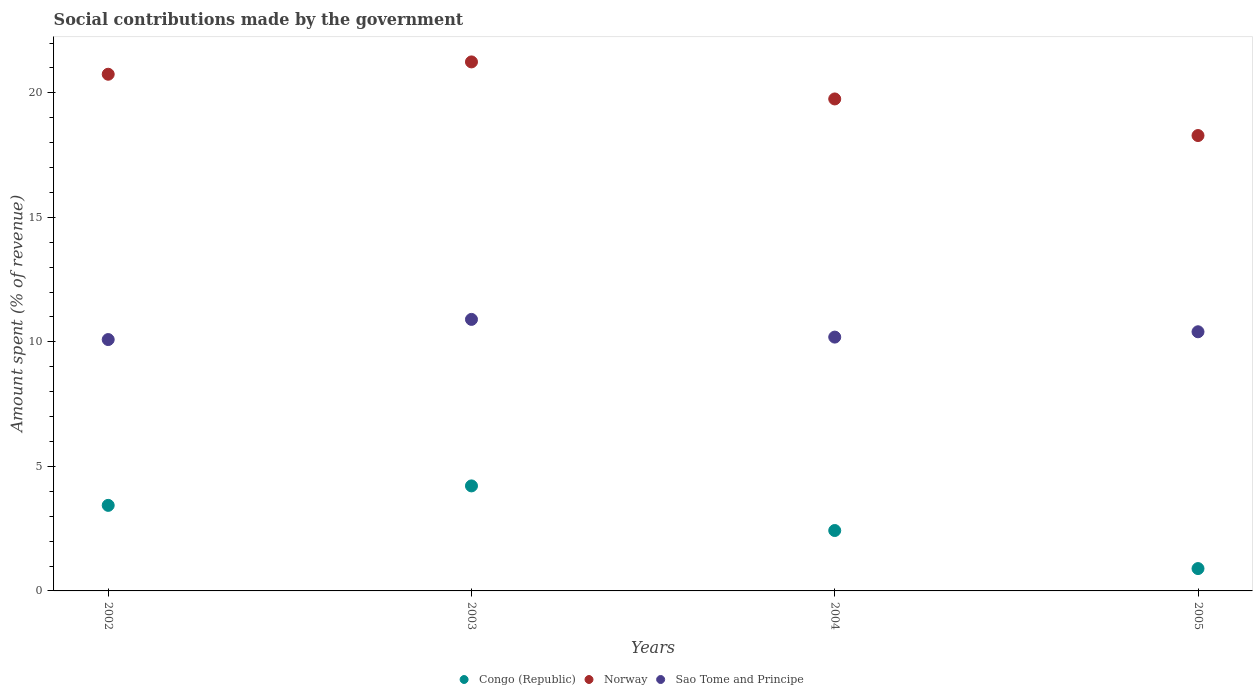What is the amount spent (in %) on social contributions in Congo (Republic) in 2003?
Keep it short and to the point. 4.22. Across all years, what is the maximum amount spent (in %) on social contributions in Sao Tome and Principe?
Offer a terse response. 10.9. Across all years, what is the minimum amount spent (in %) on social contributions in Sao Tome and Principe?
Make the answer very short. 10.09. In which year was the amount spent (in %) on social contributions in Sao Tome and Principe maximum?
Provide a succinct answer. 2003. What is the total amount spent (in %) on social contributions in Congo (Republic) in the graph?
Provide a succinct answer. 10.98. What is the difference between the amount spent (in %) on social contributions in Congo (Republic) in 2002 and that in 2003?
Offer a terse response. -0.78. What is the difference between the amount spent (in %) on social contributions in Norway in 2004 and the amount spent (in %) on social contributions in Congo (Republic) in 2005?
Your answer should be compact. 18.86. What is the average amount spent (in %) on social contributions in Congo (Republic) per year?
Your answer should be very brief. 2.74. In the year 2005, what is the difference between the amount spent (in %) on social contributions in Sao Tome and Principe and amount spent (in %) on social contributions in Norway?
Give a very brief answer. -7.88. In how many years, is the amount spent (in %) on social contributions in Sao Tome and Principe greater than 15 %?
Make the answer very short. 0. What is the ratio of the amount spent (in %) on social contributions in Norway in 2003 to that in 2005?
Your response must be concise. 1.16. What is the difference between the highest and the second highest amount spent (in %) on social contributions in Sao Tome and Principe?
Offer a very short reply. 0.5. What is the difference between the highest and the lowest amount spent (in %) on social contributions in Sao Tome and Principe?
Your response must be concise. 0.81. Is the sum of the amount spent (in %) on social contributions in Congo (Republic) in 2003 and 2005 greater than the maximum amount spent (in %) on social contributions in Norway across all years?
Give a very brief answer. No. Is it the case that in every year, the sum of the amount spent (in %) on social contributions in Congo (Republic) and amount spent (in %) on social contributions in Sao Tome and Principe  is greater than the amount spent (in %) on social contributions in Norway?
Ensure brevity in your answer.  No. Is the amount spent (in %) on social contributions in Norway strictly greater than the amount spent (in %) on social contributions in Sao Tome and Principe over the years?
Give a very brief answer. Yes. How many years are there in the graph?
Keep it short and to the point. 4. Are the values on the major ticks of Y-axis written in scientific E-notation?
Ensure brevity in your answer.  No. Does the graph contain any zero values?
Your answer should be compact. No. How are the legend labels stacked?
Offer a very short reply. Horizontal. What is the title of the graph?
Offer a very short reply. Social contributions made by the government. Does "Seychelles" appear as one of the legend labels in the graph?
Keep it short and to the point. No. What is the label or title of the X-axis?
Give a very brief answer. Years. What is the label or title of the Y-axis?
Offer a very short reply. Amount spent (% of revenue). What is the Amount spent (% of revenue) in Congo (Republic) in 2002?
Your answer should be compact. 3.44. What is the Amount spent (% of revenue) in Norway in 2002?
Provide a short and direct response. 20.75. What is the Amount spent (% of revenue) in Sao Tome and Principe in 2002?
Keep it short and to the point. 10.09. What is the Amount spent (% of revenue) in Congo (Republic) in 2003?
Keep it short and to the point. 4.22. What is the Amount spent (% of revenue) in Norway in 2003?
Offer a terse response. 21.24. What is the Amount spent (% of revenue) in Sao Tome and Principe in 2003?
Keep it short and to the point. 10.9. What is the Amount spent (% of revenue) in Congo (Republic) in 2004?
Ensure brevity in your answer.  2.43. What is the Amount spent (% of revenue) in Norway in 2004?
Your answer should be compact. 19.76. What is the Amount spent (% of revenue) of Sao Tome and Principe in 2004?
Offer a terse response. 10.19. What is the Amount spent (% of revenue) in Congo (Republic) in 2005?
Provide a short and direct response. 0.9. What is the Amount spent (% of revenue) in Norway in 2005?
Offer a terse response. 18.29. What is the Amount spent (% of revenue) in Sao Tome and Principe in 2005?
Provide a short and direct response. 10.41. Across all years, what is the maximum Amount spent (% of revenue) of Congo (Republic)?
Keep it short and to the point. 4.22. Across all years, what is the maximum Amount spent (% of revenue) of Norway?
Make the answer very short. 21.24. Across all years, what is the maximum Amount spent (% of revenue) in Sao Tome and Principe?
Provide a succinct answer. 10.9. Across all years, what is the minimum Amount spent (% of revenue) of Congo (Republic)?
Offer a terse response. 0.9. Across all years, what is the minimum Amount spent (% of revenue) of Norway?
Offer a terse response. 18.29. Across all years, what is the minimum Amount spent (% of revenue) in Sao Tome and Principe?
Provide a succinct answer. 10.09. What is the total Amount spent (% of revenue) in Congo (Republic) in the graph?
Your answer should be very brief. 10.98. What is the total Amount spent (% of revenue) of Norway in the graph?
Offer a very short reply. 80.03. What is the total Amount spent (% of revenue) in Sao Tome and Principe in the graph?
Ensure brevity in your answer.  41.6. What is the difference between the Amount spent (% of revenue) of Congo (Republic) in 2002 and that in 2003?
Offer a very short reply. -0.78. What is the difference between the Amount spent (% of revenue) of Norway in 2002 and that in 2003?
Offer a very short reply. -0.5. What is the difference between the Amount spent (% of revenue) of Sao Tome and Principe in 2002 and that in 2003?
Your answer should be compact. -0.81. What is the difference between the Amount spent (% of revenue) in Norway in 2002 and that in 2004?
Give a very brief answer. 0.99. What is the difference between the Amount spent (% of revenue) in Sao Tome and Principe in 2002 and that in 2004?
Keep it short and to the point. -0.1. What is the difference between the Amount spent (% of revenue) of Congo (Republic) in 2002 and that in 2005?
Ensure brevity in your answer.  2.54. What is the difference between the Amount spent (% of revenue) in Norway in 2002 and that in 2005?
Provide a succinct answer. 2.46. What is the difference between the Amount spent (% of revenue) of Sao Tome and Principe in 2002 and that in 2005?
Provide a short and direct response. -0.31. What is the difference between the Amount spent (% of revenue) of Congo (Republic) in 2003 and that in 2004?
Provide a short and direct response. 1.79. What is the difference between the Amount spent (% of revenue) in Norway in 2003 and that in 2004?
Offer a very short reply. 1.49. What is the difference between the Amount spent (% of revenue) in Sao Tome and Principe in 2003 and that in 2004?
Your response must be concise. 0.71. What is the difference between the Amount spent (% of revenue) of Congo (Republic) in 2003 and that in 2005?
Ensure brevity in your answer.  3.32. What is the difference between the Amount spent (% of revenue) of Norway in 2003 and that in 2005?
Ensure brevity in your answer.  2.96. What is the difference between the Amount spent (% of revenue) of Sao Tome and Principe in 2003 and that in 2005?
Provide a short and direct response. 0.5. What is the difference between the Amount spent (% of revenue) of Congo (Republic) in 2004 and that in 2005?
Provide a succinct answer. 1.53. What is the difference between the Amount spent (% of revenue) in Norway in 2004 and that in 2005?
Ensure brevity in your answer.  1.47. What is the difference between the Amount spent (% of revenue) of Sao Tome and Principe in 2004 and that in 2005?
Keep it short and to the point. -0.21. What is the difference between the Amount spent (% of revenue) in Congo (Republic) in 2002 and the Amount spent (% of revenue) in Norway in 2003?
Offer a very short reply. -17.81. What is the difference between the Amount spent (% of revenue) in Congo (Republic) in 2002 and the Amount spent (% of revenue) in Sao Tome and Principe in 2003?
Make the answer very short. -7.47. What is the difference between the Amount spent (% of revenue) of Norway in 2002 and the Amount spent (% of revenue) of Sao Tome and Principe in 2003?
Offer a terse response. 9.84. What is the difference between the Amount spent (% of revenue) of Congo (Republic) in 2002 and the Amount spent (% of revenue) of Norway in 2004?
Provide a succinct answer. -16.32. What is the difference between the Amount spent (% of revenue) in Congo (Republic) in 2002 and the Amount spent (% of revenue) in Sao Tome and Principe in 2004?
Give a very brief answer. -6.76. What is the difference between the Amount spent (% of revenue) of Norway in 2002 and the Amount spent (% of revenue) of Sao Tome and Principe in 2004?
Offer a very short reply. 10.56. What is the difference between the Amount spent (% of revenue) in Congo (Republic) in 2002 and the Amount spent (% of revenue) in Norway in 2005?
Ensure brevity in your answer.  -14.85. What is the difference between the Amount spent (% of revenue) of Congo (Republic) in 2002 and the Amount spent (% of revenue) of Sao Tome and Principe in 2005?
Your response must be concise. -6.97. What is the difference between the Amount spent (% of revenue) of Norway in 2002 and the Amount spent (% of revenue) of Sao Tome and Principe in 2005?
Your response must be concise. 10.34. What is the difference between the Amount spent (% of revenue) of Congo (Republic) in 2003 and the Amount spent (% of revenue) of Norway in 2004?
Make the answer very short. -15.54. What is the difference between the Amount spent (% of revenue) in Congo (Republic) in 2003 and the Amount spent (% of revenue) in Sao Tome and Principe in 2004?
Your response must be concise. -5.98. What is the difference between the Amount spent (% of revenue) of Norway in 2003 and the Amount spent (% of revenue) of Sao Tome and Principe in 2004?
Your answer should be compact. 11.05. What is the difference between the Amount spent (% of revenue) in Congo (Republic) in 2003 and the Amount spent (% of revenue) in Norway in 2005?
Ensure brevity in your answer.  -14.07. What is the difference between the Amount spent (% of revenue) in Congo (Republic) in 2003 and the Amount spent (% of revenue) in Sao Tome and Principe in 2005?
Your response must be concise. -6.19. What is the difference between the Amount spent (% of revenue) of Norway in 2003 and the Amount spent (% of revenue) of Sao Tome and Principe in 2005?
Give a very brief answer. 10.84. What is the difference between the Amount spent (% of revenue) in Congo (Republic) in 2004 and the Amount spent (% of revenue) in Norway in 2005?
Ensure brevity in your answer.  -15.86. What is the difference between the Amount spent (% of revenue) of Congo (Republic) in 2004 and the Amount spent (% of revenue) of Sao Tome and Principe in 2005?
Your answer should be compact. -7.98. What is the difference between the Amount spent (% of revenue) of Norway in 2004 and the Amount spent (% of revenue) of Sao Tome and Principe in 2005?
Offer a terse response. 9.35. What is the average Amount spent (% of revenue) in Congo (Republic) per year?
Provide a succinct answer. 2.74. What is the average Amount spent (% of revenue) of Norway per year?
Keep it short and to the point. 20.01. What is the average Amount spent (% of revenue) in Sao Tome and Principe per year?
Provide a short and direct response. 10.4. In the year 2002, what is the difference between the Amount spent (% of revenue) in Congo (Republic) and Amount spent (% of revenue) in Norway?
Provide a succinct answer. -17.31. In the year 2002, what is the difference between the Amount spent (% of revenue) in Congo (Republic) and Amount spent (% of revenue) in Sao Tome and Principe?
Give a very brief answer. -6.66. In the year 2002, what is the difference between the Amount spent (% of revenue) in Norway and Amount spent (% of revenue) in Sao Tome and Principe?
Give a very brief answer. 10.65. In the year 2003, what is the difference between the Amount spent (% of revenue) in Congo (Republic) and Amount spent (% of revenue) in Norway?
Keep it short and to the point. -17.03. In the year 2003, what is the difference between the Amount spent (% of revenue) in Congo (Republic) and Amount spent (% of revenue) in Sao Tome and Principe?
Offer a very short reply. -6.69. In the year 2003, what is the difference between the Amount spent (% of revenue) in Norway and Amount spent (% of revenue) in Sao Tome and Principe?
Make the answer very short. 10.34. In the year 2004, what is the difference between the Amount spent (% of revenue) in Congo (Republic) and Amount spent (% of revenue) in Norway?
Give a very brief answer. -17.33. In the year 2004, what is the difference between the Amount spent (% of revenue) in Congo (Republic) and Amount spent (% of revenue) in Sao Tome and Principe?
Provide a short and direct response. -7.77. In the year 2004, what is the difference between the Amount spent (% of revenue) in Norway and Amount spent (% of revenue) in Sao Tome and Principe?
Your response must be concise. 9.56. In the year 2005, what is the difference between the Amount spent (% of revenue) in Congo (Republic) and Amount spent (% of revenue) in Norway?
Your answer should be very brief. -17.39. In the year 2005, what is the difference between the Amount spent (% of revenue) of Congo (Republic) and Amount spent (% of revenue) of Sao Tome and Principe?
Make the answer very short. -9.51. In the year 2005, what is the difference between the Amount spent (% of revenue) in Norway and Amount spent (% of revenue) in Sao Tome and Principe?
Give a very brief answer. 7.88. What is the ratio of the Amount spent (% of revenue) in Congo (Republic) in 2002 to that in 2003?
Offer a terse response. 0.81. What is the ratio of the Amount spent (% of revenue) in Norway in 2002 to that in 2003?
Your response must be concise. 0.98. What is the ratio of the Amount spent (% of revenue) of Sao Tome and Principe in 2002 to that in 2003?
Ensure brevity in your answer.  0.93. What is the ratio of the Amount spent (% of revenue) of Congo (Republic) in 2002 to that in 2004?
Provide a short and direct response. 1.42. What is the ratio of the Amount spent (% of revenue) in Norway in 2002 to that in 2004?
Your answer should be very brief. 1.05. What is the ratio of the Amount spent (% of revenue) of Sao Tome and Principe in 2002 to that in 2004?
Your response must be concise. 0.99. What is the ratio of the Amount spent (% of revenue) of Congo (Republic) in 2002 to that in 2005?
Offer a terse response. 3.83. What is the ratio of the Amount spent (% of revenue) in Norway in 2002 to that in 2005?
Your answer should be compact. 1.13. What is the ratio of the Amount spent (% of revenue) in Sao Tome and Principe in 2002 to that in 2005?
Give a very brief answer. 0.97. What is the ratio of the Amount spent (% of revenue) of Congo (Republic) in 2003 to that in 2004?
Offer a terse response. 1.74. What is the ratio of the Amount spent (% of revenue) of Norway in 2003 to that in 2004?
Your answer should be compact. 1.08. What is the ratio of the Amount spent (% of revenue) of Sao Tome and Principe in 2003 to that in 2004?
Offer a terse response. 1.07. What is the ratio of the Amount spent (% of revenue) of Congo (Republic) in 2003 to that in 2005?
Provide a short and direct response. 4.7. What is the ratio of the Amount spent (% of revenue) of Norway in 2003 to that in 2005?
Keep it short and to the point. 1.16. What is the ratio of the Amount spent (% of revenue) in Sao Tome and Principe in 2003 to that in 2005?
Keep it short and to the point. 1.05. What is the ratio of the Amount spent (% of revenue) in Congo (Republic) in 2004 to that in 2005?
Offer a very short reply. 2.7. What is the ratio of the Amount spent (% of revenue) of Norway in 2004 to that in 2005?
Offer a terse response. 1.08. What is the ratio of the Amount spent (% of revenue) of Sao Tome and Principe in 2004 to that in 2005?
Provide a succinct answer. 0.98. What is the difference between the highest and the second highest Amount spent (% of revenue) of Congo (Republic)?
Your response must be concise. 0.78. What is the difference between the highest and the second highest Amount spent (% of revenue) of Norway?
Your answer should be very brief. 0.5. What is the difference between the highest and the second highest Amount spent (% of revenue) of Sao Tome and Principe?
Give a very brief answer. 0.5. What is the difference between the highest and the lowest Amount spent (% of revenue) of Congo (Republic)?
Keep it short and to the point. 3.32. What is the difference between the highest and the lowest Amount spent (% of revenue) of Norway?
Your answer should be compact. 2.96. What is the difference between the highest and the lowest Amount spent (% of revenue) of Sao Tome and Principe?
Your answer should be compact. 0.81. 